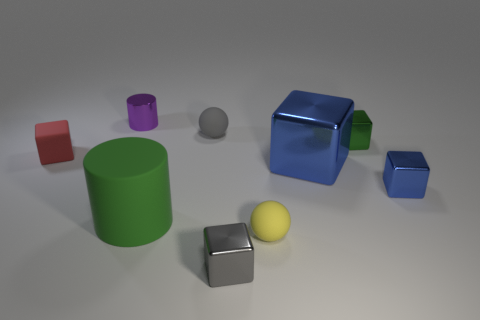Subtract all yellow spheres. How many blue cubes are left? 2 Subtract all large blue shiny blocks. How many blocks are left? 4 Add 1 big objects. How many objects exist? 10 Subtract all yellow balls. How many balls are left? 1 Subtract all balls. How many objects are left? 7 Subtract all purple cubes. Subtract all blue balls. How many cubes are left? 5 Subtract all large gray objects. Subtract all blue shiny cubes. How many objects are left? 7 Add 3 balls. How many balls are left? 5 Add 6 tiny yellow matte balls. How many tiny yellow matte balls exist? 7 Subtract 2 blue cubes. How many objects are left? 7 